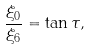<formula> <loc_0><loc_0><loc_500><loc_500>\frac { \xi _ { 0 } } { \xi _ { 6 } } = \tan \tau ,</formula> 